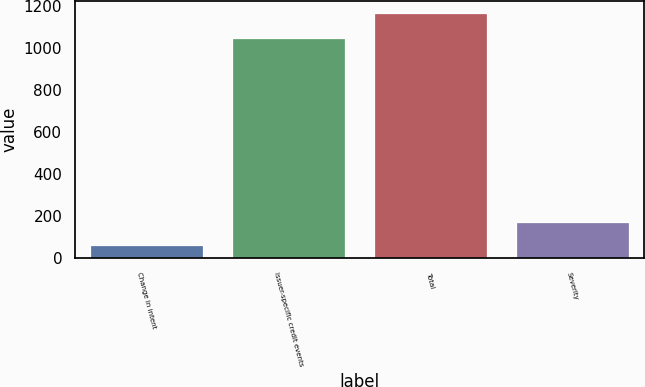Convert chart. <chart><loc_0><loc_0><loc_500><loc_500><bar_chart><fcel>Change in intent<fcel>Issuer-specific credit events<fcel>Total<fcel>Severity<nl><fcel>62<fcel>1048<fcel>1167<fcel>172.5<nl></chart> 